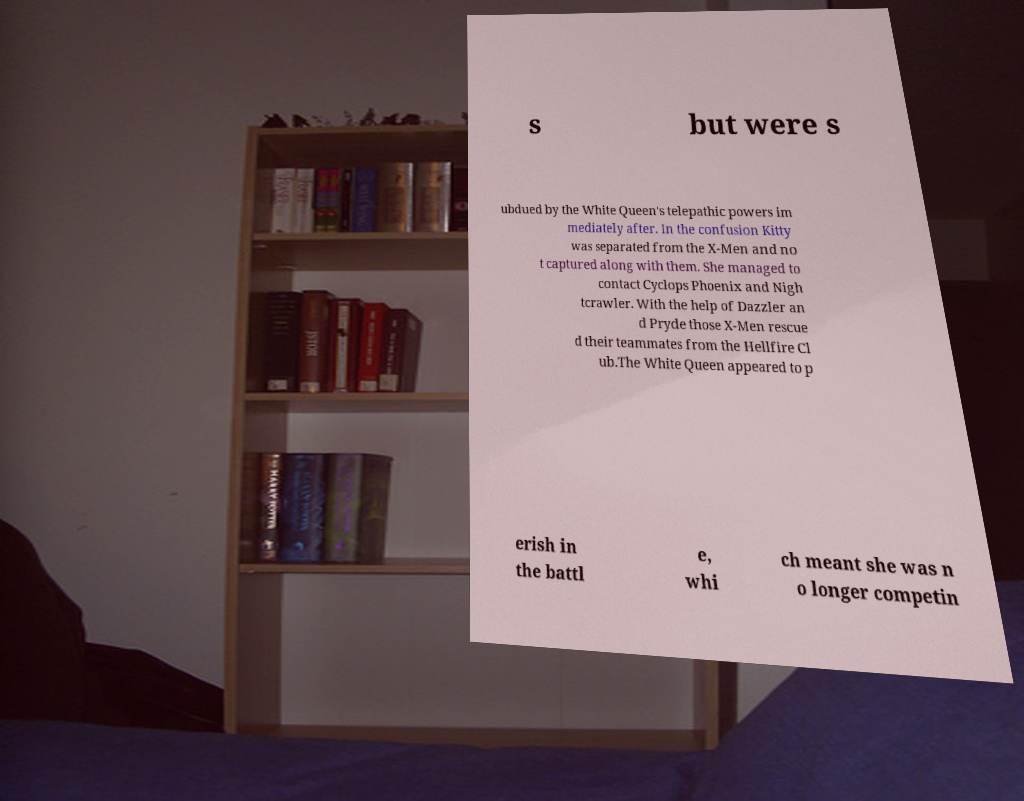Can you read and provide the text displayed in the image?This photo seems to have some interesting text. Can you extract and type it out for me? s but were s ubdued by the White Queen's telepathic powers im mediately after. In the confusion Kitty was separated from the X-Men and no t captured along with them. She managed to contact Cyclops Phoenix and Nigh tcrawler. With the help of Dazzler an d Pryde those X-Men rescue d their teammates from the Hellfire Cl ub.The White Queen appeared to p erish in the battl e, whi ch meant she was n o longer competin 